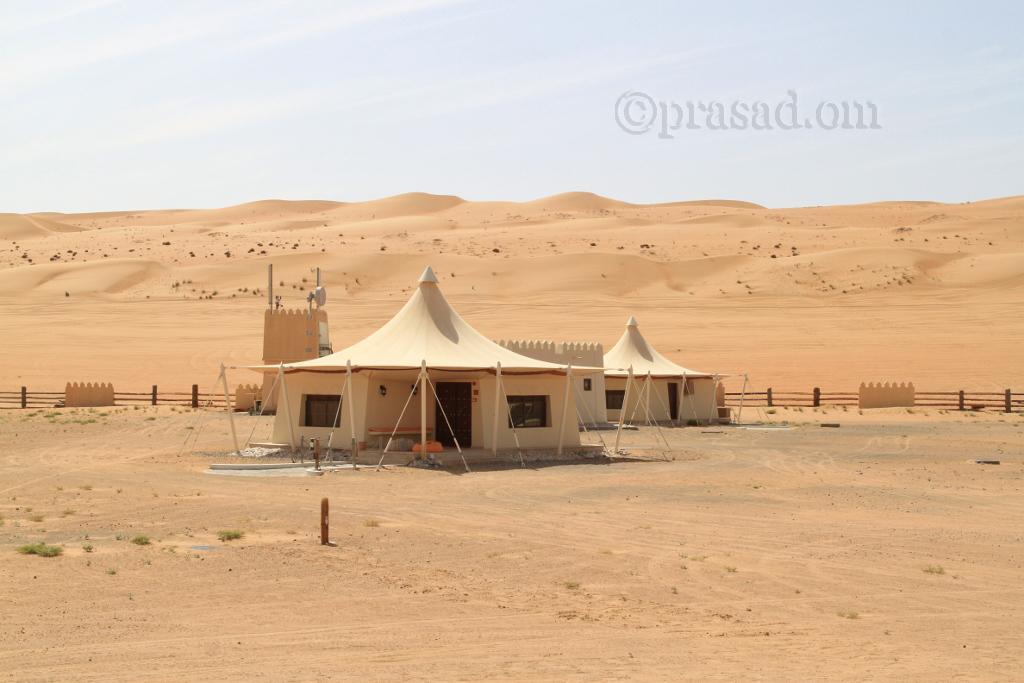Please provide a concise description of this image. In this picture we can see tent and the monument on the ground. On the right we can see a wooden fencing. In the background we can see sand desert. At the top we can see sky and clouds. At the bottom left we can see the grass. At the top right there is a watermark. 